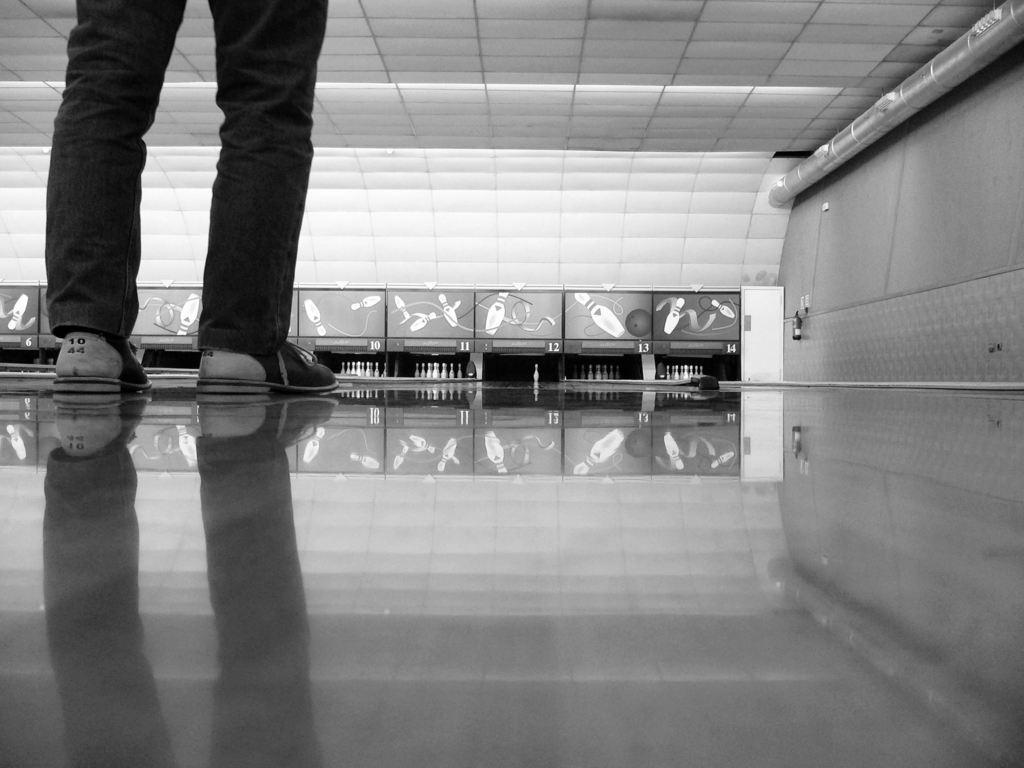Please provide a concise description of this image. It looks like a black and white picture. We can see the legs of a person. In front of the person there are bowling alleys and boards. On the right side of the image, it looks like a fire extinguisher and a pipe. 